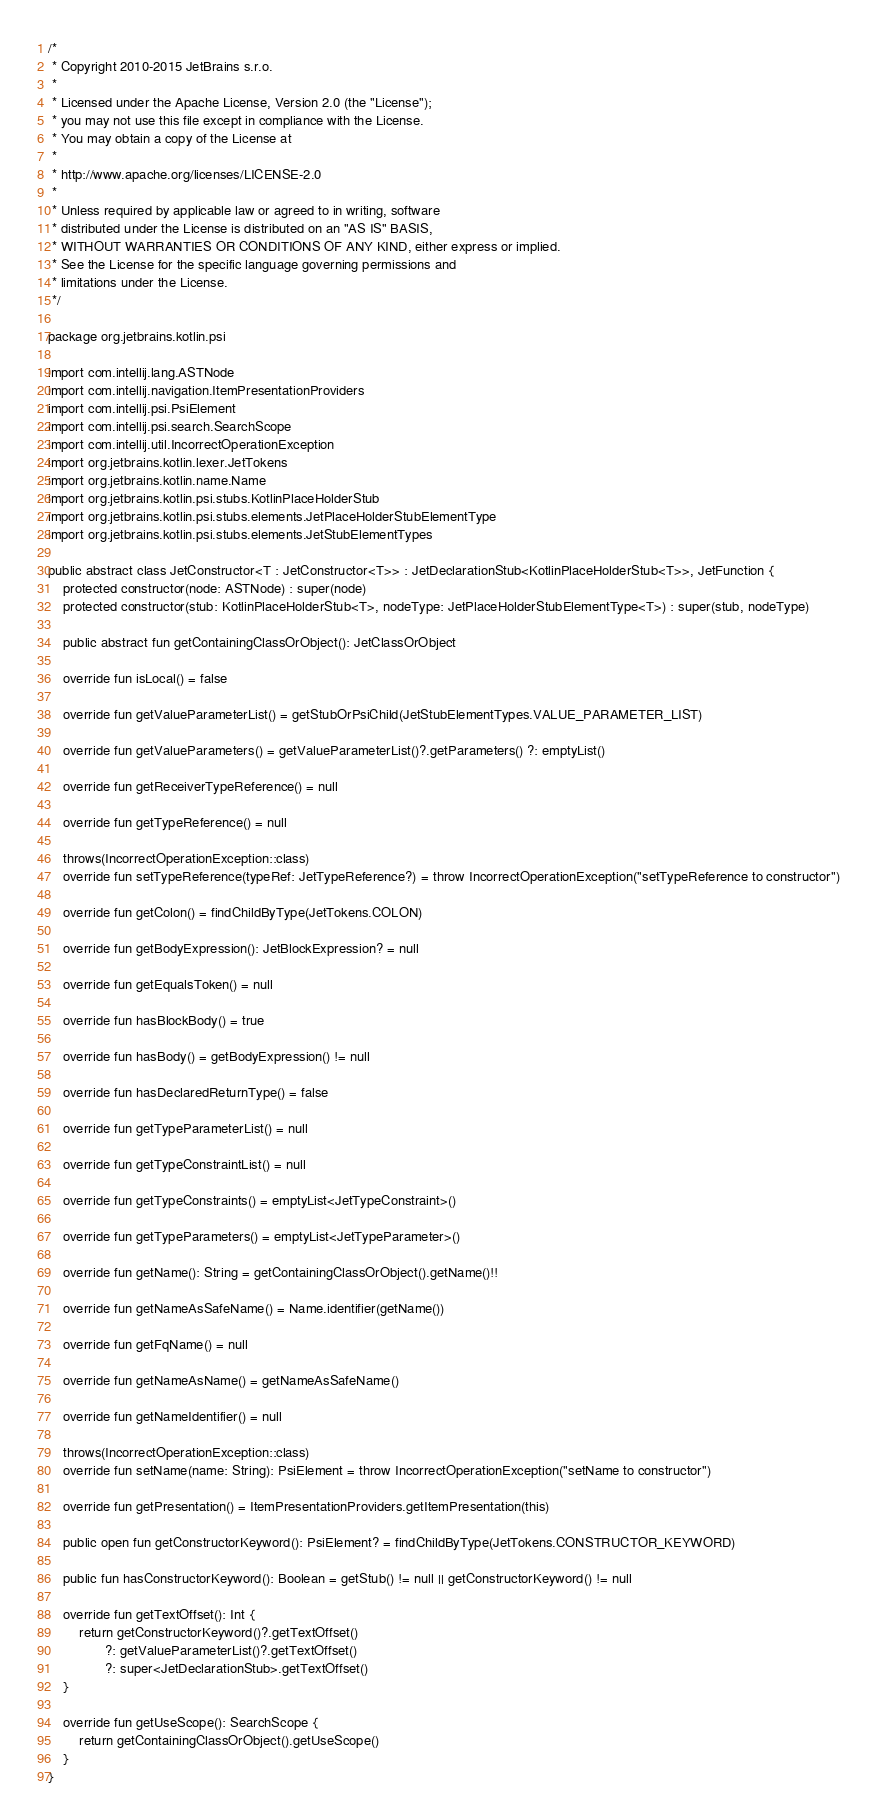Convert code to text. <code><loc_0><loc_0><loc_500><loc_500><_Kotlin_>/*
 * Copyright 2010-2015 JetBrains s.r.o.
 *
 * Licensed under the Apache License, Version 2.0 (the "License");
 * you may not use this file except in compliance with the License.
 * You may obtain a copy of the License at
 *
 * http://www.apache.org/licenses/LICENSE-2.0
 *
 * Unless required by applicable law or agreed to in writing, software
 * distributed under the License is distributed on an "AS IS" BASIS,
 * WITHOUT WARRANTIES OR CONDITIONS OF ANY KIND, either express or implied.
 * See the License for the specific language governing permissions and
 * limitations under the License.
 */

package org.jetbrains.kotlin.psi

import com.intellij.lang.ASTNode
import com.intellij.navigation.ItemPresentationProviders
import com.intellij.psi.PsiElement
import com.intellij.psi.search.SearchScope
import com.intellij.util.IncorrectOperationException
import org.jetbrains.kotlin.lexer.JetTokens
import org.jetbrains.kotlin.name.Name
import org.jetbrains.kotlin.psi.stubs.KotlinPlaceHolderStub
import org.jetbrains.kotlin.psi.stubs.elements.JetPlaceHolderStubElementType
import org.jetbrains.kotlin.psi.stubs.elements.JetStubElementTypes

public abstract class JetConstructor<T : JetConstructor<T>> : JetDeclarationStub<KotlinPlaceHolderStub<T>>, JetFunction {
    protected constructor(node: ASTNode) : super(node)
    protected constructor(stub: KotlinPlaceHolderStub<T>, nodeType: JetPlaceHolderStubElementType<T>) : super(stub, nodeType)

    public abstract fun getContainingClassOrObject(): JetClassOrObject

    override fun isLocal() = false

    override fun getValueParameterList() = getStubOrPsiChild(JetStubElementTypes.VALUE_PARAMETER_LIST)

    override fun getValueParameters() = getValueParameterList()?.getParameters() ?: emptyList()

    override fun getReceiverTypeReference() = null

    override fun getTypeReference() = null

    throws(IncorrectOperationException::class)
    override fun setTypeReference(typeRef: JetTypeReference?) = throw IncorrectOperationException("setTypeReference to constructor")

    override fun getColon() = findChildByType(JetTokens.COLON)

    override fun getBodyExpression(): JetBlockExpression? = null

    override fun getEqualsToken() = null

    override fun hasBlockBody() = true

    override fun hasBody() = getBodyExpression() != null

    override fun hasDeclaredReturnType() = false

    override fun getTypeParameterList() = null

    override fun getTypeConstraintList() = null

    override fun getTypeConstraints() = emptyList<JetTypeConstraint>()

    override fun getTypeParameters() = emptyList<JetTypeParameter>()

    override fun getName(): String = getContainingClassOrObject().getName()!!

    override fun getNameAsSafeName() = Name.identifier(getName())

    override fun getFqName() = null

    override fun getNameAsName() = getNameAsSafeName()

    override fun getNameIdentifier() = null

    throws(IncorrectOperationException::class)
    override fun setName(name: String): PsiElement = throw IncorrectOperationException("setName to constructor")

    override fun getPresentation() = ItemPresentationProviders.getItemPresentation(this)

    public open fun getConstructorKeyword(): PsiElement? = findChildByType(JetTokens.CONSTRUCTOR_KEYWORD)

    public fun hasConstructorKeyword(): Boolean = getStub() != null || getConstructorKeyword() != null

    override fun getTextOffset(): Int {
        return getConstructorKeyword()?.getTextOffset()
               ?: getValueParameterList()?.getTextOffset()
               ?: super<JetDeclarationStub>.getTextOffset()
    }

    override fun getUseScope(): SearchScope {
        return getContainingClassOrObject().getUseScope()
    }
}
</code> 